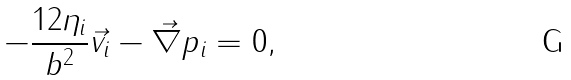<formula> <loc_0><loc_0><loc_500><loc_500>- \frac { 1 2 \eta _ { i } } { b ^ { 2 } } \vec { v } _ { i } - \vec { \nabla } p _ { i } = 0 ,</formula> 